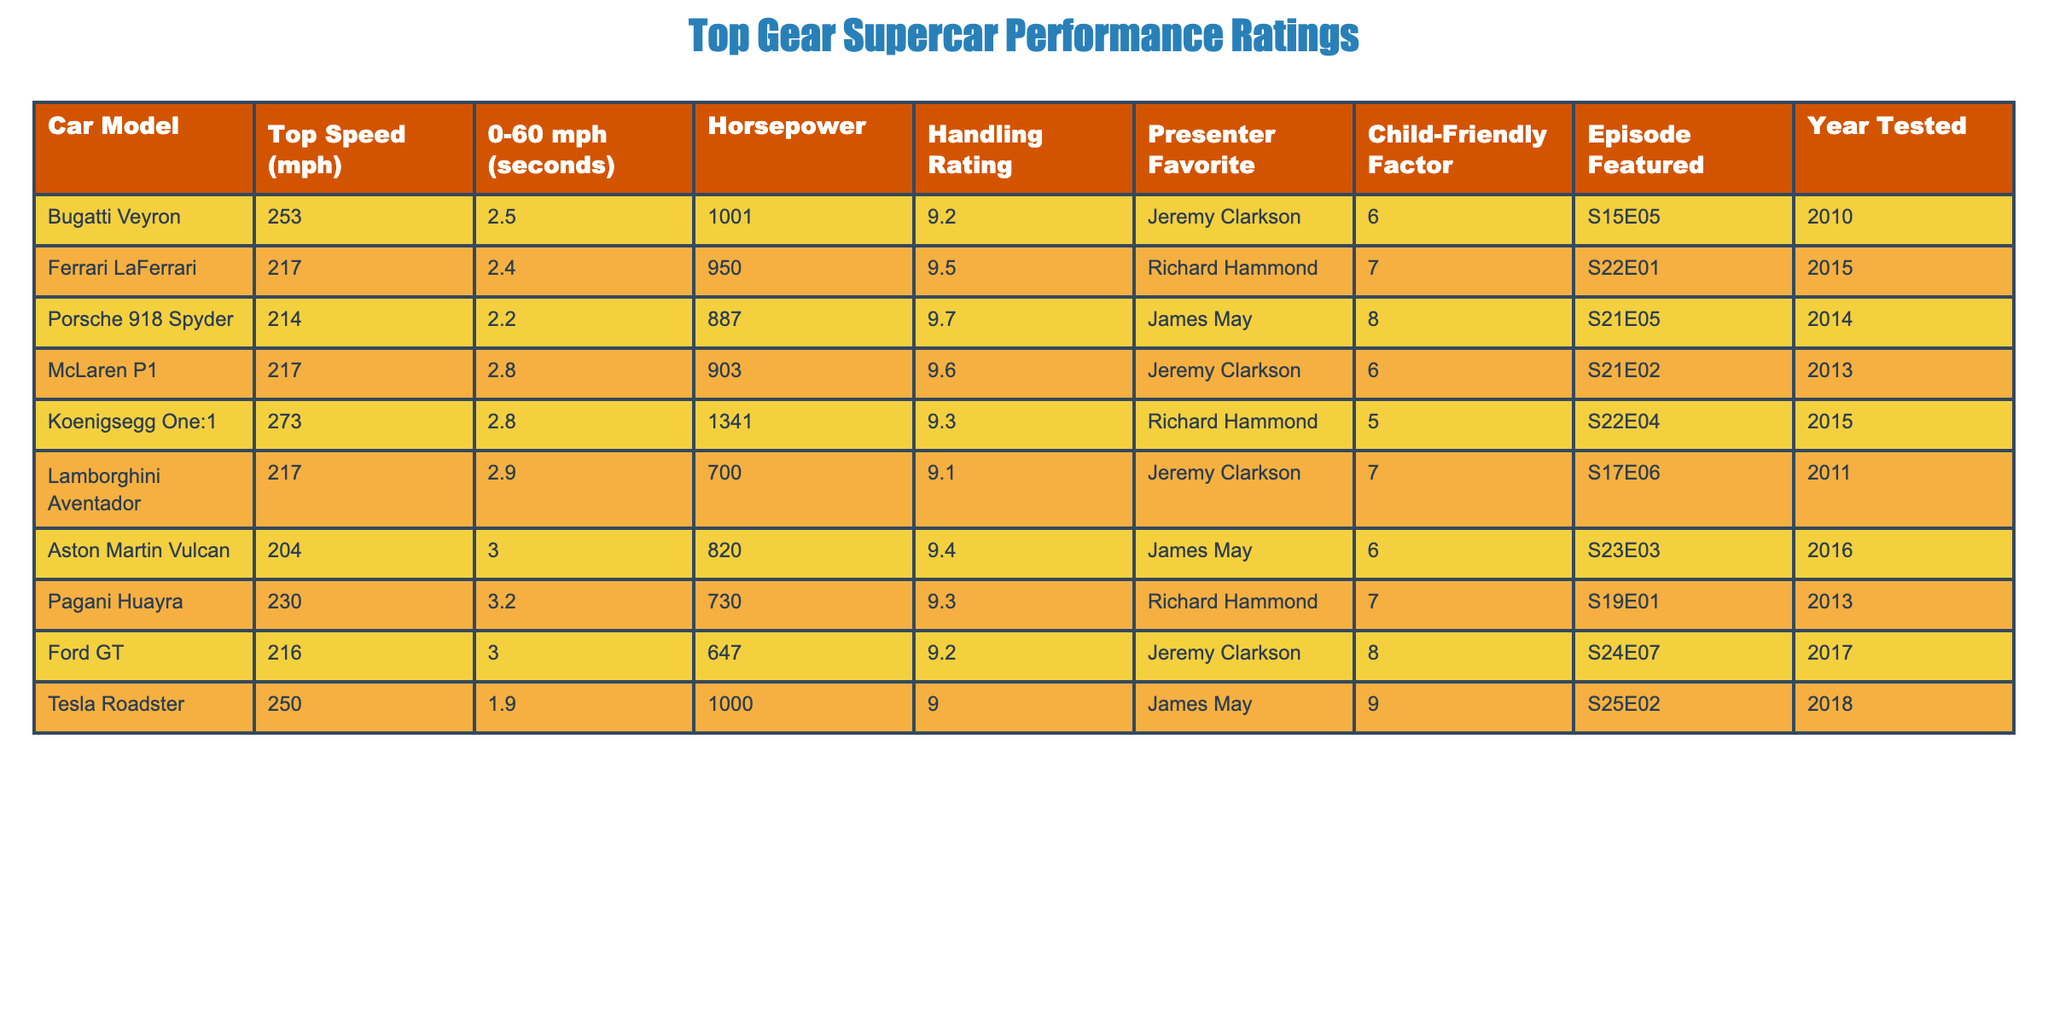What is the top speed of the Bugatti Veyron? The Bugatti Veyron's top speed is listed in the table under the "Top Speed (mph)" column. It shows as 253 mph.
Answer: 253 mph Which car has the fastest 0-60 mph acceleration time? By inspecting the "0-60 mph (seconds)" column, we see that the Tesla Roadster has the fastest acceleration time of 1.9 seconds.
Answer: 1.9 seconds How many horsepower does the Koenigsegg One:1 have? The Koenigsegg One:1's horsepower is found in the "Horsepower" column, which shows 1341 horsepower.
Answer: 1341 horsepower Is the Ford GT the child-friendly factor highest-rated car? The highest "Child-Friendly Factor" is seen next to the Tesla Roadster with a rating of 9, while the Ford GT has a rating of 8. Therefore, the Ford GT is not the highest-rated car.
Answer: No What is the average handling rating of all the cars listed? To find the average handling rating, sum the handling ratings (9.2 + 9.5 + 9.7 + 9.6 + 9.3 + 9.1 + 9.4 + 9.3 + 9.2 + 9.0 = 95.8) and divide by the number of cars (10). The average handling rating is 95.8 / 10 = 9.58.
Answer: 9.58 Which presenter had a favorite car with the highest horsepower? Looking at the "Horsepower" column and the corresponding "Presenter Favorite" for each car, the Koenigsegg One:1 (1341 horsepower) is favored by Richard Hammond, which is the highest.
Answer: Richard Hammond Which supercar was featured in the most recent episode? The most recent episode based on the "Year Tested" column is the Tesla Roadster from 2018, which is featured in episode S25E02.
Answer: Tesla Roadster What is the difference in top speed between the Porsche 918 Spyder and the Lamborghini Aventador? The top speed of the Porsche 918 Spyder is 214 mph, and the Lamborghini Aventador's top speed is 217 mph. The difference is 217 - 214 = 3 mph.
Answer: 3 mph How many supercars have a handling rating above 9.5? By checking the "Handling Rating" column, only the Ferrari LaFerrari (9.5), Porsche 918 Spyder (9.7), and McLaren P1 (9.6) qualify for this, making a total of 3 supercars.
Answer: 3 supercars What percentage of the cars tested had a child-friendly factor of 6 or higher? There are 10 cars, and the following have a child-friendly factor of 6 or higher: Bugatti Veyron, McLaren P1, Aston Martin Vulcan, and Ford GT. That is 4 out of 10 cars. The percentage is (4 / 10) * 100 = 40%.
Answer: 40% 